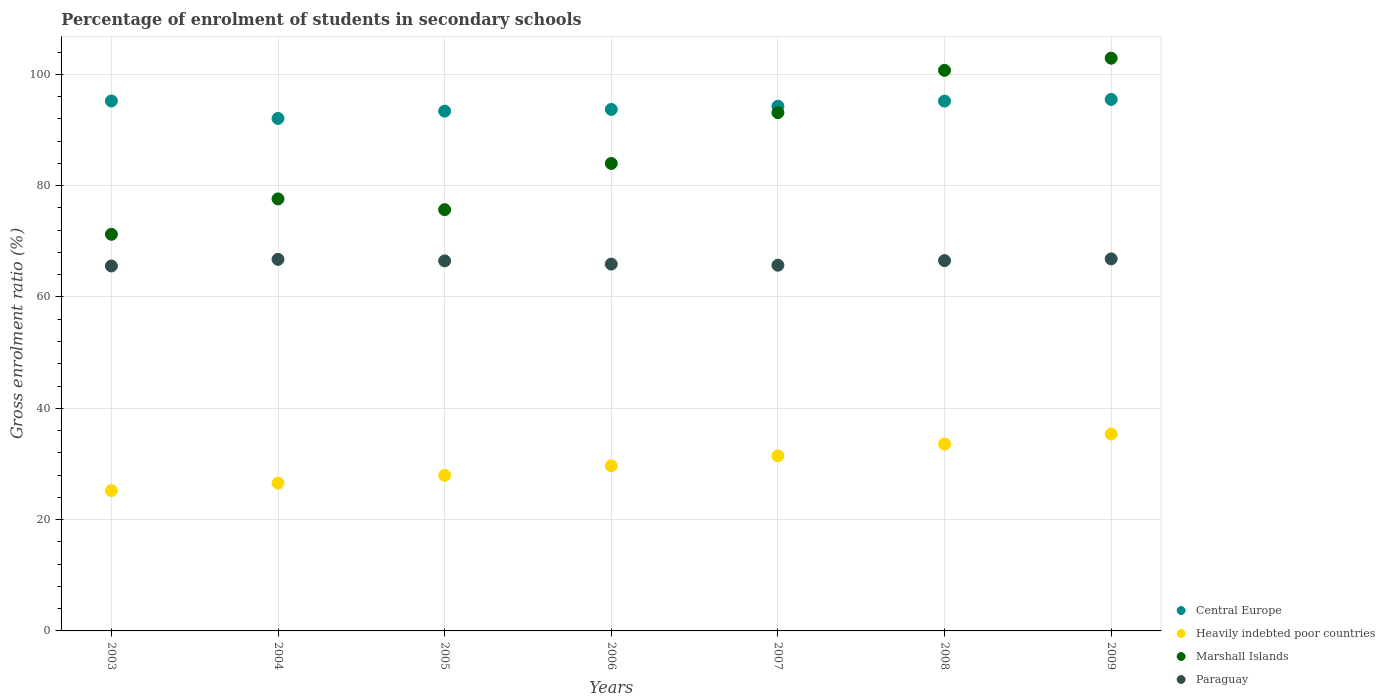What is the percentage of students enrolled in secondary schools in Heavily indebted poor countries in 2006?
Keep it short and to the point. 29.67. Across all years, what is the maximum percentage of students enrolled in secondary schools in Marshall Islands?
Your answer should be very brief. 102.89. Across all years, what is the minimum percentage of students enrolled in secondary schools in Central Europe?
Your answer should be very brief. 92.07. In which year was the percentage of students enrolled in secondary schools in Paraguay maximum?
Offer a terse response. 2009. What is the total percentage of students enrolled in secondary schools in Paraguay in the graph?
Provide a succinct answer. 463.77. What is the difference between the percentage of students enrolled in secondary schools in Paraguay in 2008 and that in 2009?
Provide a succinct answer. -0.3. What is the difference between the percentage of students enrolled in secondary schools in Paraguay in 2005 and the percentage of students enrolled in secondary schools in Central Europe in 2008?
Give a very brief answer. -28.71. What is the average percentage of students enrolled in secondary schools in Marshall Islands per year?
Provide a succinct answer. 86.47. In the year 2003, what is the difference between the percentage of students enrolled in secondary schools in Heavily indebted poor countries and percentage of students enrolled in secondary schools in Marshall Islands?
Provide a short and direct response. -46.05. What is the ratio of the percentage of students enrolled in secondary schools in Marshall Islands in 2006 to that in 2008?
Keep it short and to the point. 0.83. Is the difference between the percentage of students enrolled in secondary schools in Heavily indebted poor countries in 2007 and 2008 greater than the difference between the percentage of students enrolled in secondary schools in Marshall Islands in 2007 and 2008?
Ensure brevity in your answer.  Yes. What is the difference between the highest and the second highest percentage of students enrolled in secondary schools in Marshall Islands?
Your response must be concise. 2.18. What is the difference between the highest and the lowest percentage of students enrolled in secondary schools in Paraguay?
Keep it short and to the point. 1.28. Is it the case that in every year, the sum of the percentage of students enrolled in secondary schools in Central Europe and percentage of students enrolled in secondary schools in Paraguay  is greater than the sum of percentage of students enrolled in secondary schools in Heavily indebted poor countries and percentage of students enrolled in secondary schools in Marshall Islands?
Keep it short and to the point. No. Is it the case that in every year, the sum of the percentage of students enrolled in secondary schools in Heavily indebted poor countries and percentage of students enrolled in secondary schools in Paraguay  is greater than the percentage of students enrolled in secondary schools in Marshall Islands?
Offer a terse response. No. How many dotlines are there?
Provide a short and direct response. 4. How many years are there in the graph?
Provide a succinct answer. 7. What is the difference between two consecutive major ticks on the Y-axis?
Your answer should be very brief. 20. Are the values on the major ticks of Y-axis written in scientific E-notation?
Give a very brief answer. No. Does the graph contain any zero values?
Provide a succinct answer. No. Does the graph contain grids?
Your answer should be very brief. Yes. How many legend labels are there?
Provide a succinct answer. 4. How are the legend labels stacked?
Provide a succinct answer. Vertical. What is the title of the graph?
Your answer should be compact. Percentage of enrolment of students in secondary schools. Does "Brazil" appear as one of the legend labels in the graph?
Ensure brevity in your answer.  No. What is the Gross enrolment ratio (%) of Central Europe in 2003?
Make the answer very short. 95.21. What is the Gross enrolment ratio (%) in Heavily indebted poor countries in 2003?
Keep it short and to the point. 25.2. What is the Gross enrolment ratio (%) of Marshall Islands in 2003?
Keep it short and to the point. 71.26. What is the Gross enrolment ratio (%) in Paraguay in 2003?
Offer a terse response. 65.56. What is the Gross enrolment ratio (%) in Central Europe in 2004?
Ensure brevity in your answer.  92.07. What is the Gross enrolment ratio (%) in Heavily indebted poor countries in 2004?
Your answer should be compact. 26.56. What is the Gross enrolment ratio (%) in Marshall Islands in 2004?
Ensure brevity in your answer.  77.62. What is the Gross enrolment ratio (%) in Paraguay in 2004?
Offer a terse response. 66.76. What is the Gross enrolment ratio (%) in Central Europe in 2005?
Provide a succinct answer. 93.38. What is the Gross enrolment ratio (%) in Heavily indebted poor countries in 2005?
Your answer should be very brief. 27.95. What is the Gross enrolment ratio (%) in Marshall Islands in 2005?
Give a very brief answer. 75.68. What is the Gross enrolment ratio (%) in Paraguay in 2005?
Offer a terse response. 66.48. What is the Gross enrolment ratio (%) of Central Europe in 2006?
Your response must be concise. 93.69. What is the Gross enrolment ratio (%) in Heavily indebted poor countries in 2006?
Ensure brevity in your answer.  29.67. What is the Gross enrolment ratio (%) in Marshall Islands in 2006?
Keep it short and to the point. 83.98. What is the Gross enrolment ratio (%) of Paraguay in 2006?
Make the answer very short. 65.9. What is the Gross enrolment ratio (%) in Central Europe in 2007?
Keep it short and to the point. 94.27. What is the Gross enrolment ratio (%) in Heavily indebted poor countries in 2007?
Your answer should be compact. 31.45. What is the Gross enrolment ratio (%) of Marshall Islands in 2007?
Make the answer very short. 93.11. What is the Gross enrolment ratio (%) in Paraguay in 2007?
Provide a succinct answer. 65.7. What is the Gross enrolment ratio (%) in Central Europe in 2008?
Ensure brevity in your answer.  95.19. What is the Gross enrolment ratio (%) in Heavily indebted poor countries in 2008?
Your answer should be very brief. 33.57. What is the Gross enrolment ratio (%) in Marshall Islands in 2008?
Keep it short and to the point. 100.71. What is the Gross enrolment ratio (%) of Paraguay in 2008?
Keep it short and to the point. 66.53. What is the Gross enrolment ratio (%) of Central Europe in 2009?
Make the answer very short. 95.49. What is the Gross enrolment ratio (%) in Heavily indebted poor countries in 2009?
Make the answer very short. 35.37. What is the Gross enrolment ratio (%) in Marshall Islands in 2009?
Provide a short and direct response. 102.89. What is the Gross enrolment ratio (%) in Paraguay in 2009?
Make the answer very short. 66.84. Across all years, what is the maximum Gross enrolment ratio (%) of Central Europe?
Your answer should be very brief. 95.49. Across all years, what is the maximum Gross enrolment ratio (%) in Heavily indebted poor countries?
Your response must be concise. 35.37. Across all years, what is the maximum Gross enrolment ratio (%) in Marshall Islands?
Provide a short and direct response. 102.89. Across all years, what is the maximum Gross enrolment ratio (%) of Paraguay?
Keep it short and to the point. 66.84. Across all years, what is the minimum Gross enrolment ratio (%) of Central Europe?
Give a very brief answer. 92.07. Across all years, what is the minimum Gross enrolment ratio (%) of Heavily indebted poor countries?
Your answer should be very brief. 25.2. Across all years, what is the minimum Gross enrolment ratio (%) in Marshall Islands?
Give a very brief answer. 71.26. Across all years, what is the minimum Gross enrolment ratio (%) of Paraguay?
Offer a very short reply. 65.56. What is the total Gross enrolment ratio (%) of Central Europe in the graph?
Provide a short and direct response. 659.29. What is the total Gross enrolment ratio (%) in Heavily indebted poor countries in the graph?
Offer a terse response. 209.78. What is the total Gross enrolment ratio (%) of Marshall Islands in the graph?
Offer a very short reply. 605.26. What is the total Gross enrolment ratio (%) of Paraguay in the graph?
Your answer should be very brief. 463.77. What is the difference between the Gross enrolment ratio (%) of Central Europe in 2003 and that in 2004?
Keep it short and to the point. 3.14. What is the difference between the Gross enrolment ratio (%) of Heavily indebted poor countries in 2003 and that in 2004?
Give a very brief answer. -1.36. What is the difference between the Gross enrolment ratio (%) in Marshall Islands in 2003 and that in 2004?
Offer a terse response. -6.36. What is the difference between the Gross enrolment ratio (%) of Paraguay in 2003 and that in 2004?
Ensure brevity in your answer.  -1.19. What is the difference between the Gross enrolment ratio (%) in Central Europe in 2003 and that in 2005?
Give a very brief answer. 1.82. What is the difference between the Gross enrolment ratio (%) in Heavily indebted poor countries in 2003 and that in 2005?
Offer a very short reply. -2.75. What is the difference between the Gross enrolment ratio (%) of Marshall Islands in 2003 and that in 2005?
Give a very brief answer. -4.43. What is the difference between the Gross enrolment ratio (%) of Paraguay in 2003 and that in 2005?
Ensure brevity in your answer.  -0.92. What is the difference between the Gross enrolment ratio (%) in Central Europe in 2003 and that in 2006?
Your response must be concise. 1.52. What is the difference between the Gross enrolment ratio (%) in Heavily indebted poor countries in 2003 and that in 2006?
Your answer should be very brief. -4.47. What is the difference between the Gross enrolment ratio (%) in Marshall Islands in 2003 and that in 2006?
Your response must be concise. -12.73. What is the difference between the Gross enrolment ratio (%) in Paraguay in 2003 and that in 2006?
Provide a short and direct response. -0.34. What is the difference between the Gross enrolment ratio (%) of Central Europe in 2003 and that in 2007?
Offer a very short reply. 0.94. What is the difference between the Gross enrolment ratio (%) of Heavily indebted poor countries in 2003 and that in 2007?
Offer a very short reply. -6.25. What is the difference between the Gross enrolment ratio (%) of Marshall Islands in 2003 and that in 2007?
Ensure brevity in your answer.  -21.86. What is the difference between the Gross enrolment ratio (%) of Paraguay in 2003 and that in 2007?
Provide a short and direct response. -0.14. What is the difference between the Gross enrolment ratio (%) of Central Europe in 2003 and that in 2008?
Offer a very short reply. 0.02. What is the difference between the Gross enrolment ratio (%) in Heavily indebted poor countries in 2003 and that in 2008?
Offer a terse response. -8.36. What is the difference between the Gross enrolment ratio (%) of Marshall Islands in 2003 and that in 2008?
Offer a terse response. -29.46. What is the difference between the Gross enrolment ratio (%) of Paraguay in 2003 and that in 2008?
Give a very brief answer. -0.97. What is the difference between the Gross enrolment ratio (%) in Central Europe in 2003 and that in 2009?
Make the answer very short. -0.28. What is the difference between the Gross enrolment ratio (%) in Heavily indebted poor countries in 2003 and that in 2009?
Provide a short and direct response. -10.16. What is the difference between the Gross enrolment ratio (%) of Marshall Islands in 2003 and that in 2009?
Your answer should be very brief. -31.64. What is the difference between the Gross enrolment ratio (%) in Paraguay in 2003 and that in 2009?
Ensure brevity in your answer.  -1.28. What is the difference between the Gross enrolment ratio (%) of Central Europe in 2004 and that in 2005?
Your answer should be compact. -1.31. What is the difference between the Gross enrolment ratio (%) in Heavily indebted poor countries in 2004 and that in 2005?
Your answer should be very brief. -1.39. What is the difference between the Gross enrolment ratio (%) of Marshall Islands in 2004 and that in 2005?
Make the answer very short. 1.93. What is the difference between the Gross enrolment ratio (%) of Paraguay in 2004 and that in 2005?
Ensure brevity in your answer.  0.27. What is the difference between the Gross enrolment ratio (%) in Central Europe in 2004 and that in 2006?
Your answer should be compact. -1.62. What is the difference between the Gross enrolment ratio (%) of Heavily indebted poor countries in 2004 and that in 2006?
Your answer should be compact. -3.11. What is the difference between the Gross enrolment ratio (%) in Marshall Islands in 2004 and that in 2006?
Your response must be concise. -6.37. What is the difference between the Gross enrolment ratio (%) of Paraguay in 2004 and that in 2006?
Provide a short and direct response. 0.85. What is the difference between the Gross enrolment ratio (%) in Central Europe in 2004 and that in 2007?
Your response must be concise. -2.2. What is the difference between the Gross enrolment ratio (%) in Heavily indebted poor countries in 2004 and that in 2007?
Provide a succinct answer. -4.89. What is the difference between the Gross enrolment ratio (%) in Marshall Islands in 2004 and that in 2007?
Your response must be concise. -15.5. What is the difference between the Gross enrolment ratio (%) in Paraguay in 2004 and that in 2007?
Ensure brevity in your answer.  1.05. What is the difference between the Gross enrolment ratio (%) of Central Europe in 2004 and that in 2008?
Ensure brevity in your answer.  -3.12. What is the difference between the Gross enrolment ratio (%) in Heavily indebted poor countries in 2004 and that in 2008?
Provide a short and direct response. -7. What is the difference between the Gross enrolment ratio (%) of Marshall Islands in 2004 and that in 2008?
Give a very brief answer. -23.1. What is the difference between the Gross enrolment ratio (%) of Paraguay in 2004 and that in 2008?
Offer a terse response. 0.22. What is the difference between the Gross enrolment ratio (%) in Central Europe in 2004 and that in 2009?
Your response must be concise. -3.42. What is the difference between the Gross enrolment ratio (%) of Heavily indebted poor countries in 2004 and that in 2009?
Offer a terse response. -8.8. What is the difference between the Gross enrolment ratio (%) in Marshall Islands in 2004 and that in 2009?
Ensure brevity in your answer.  -25.28. What is the difference between the Gross enrolment ratio (%) in Paraguay in 2004 and that in 2009?
Make the answer very short. -0.08. What is the difference between the Gross enrolment ratio (%) of Central Europe in 2005 and that in 2006?
Keep it short and to the point. -0.31. What is the difference between the Gross enrolment ratio (%) of Heavily indebted poor countries in 2005 and that in 2006?
Provide a short and direct response. -1.72. What is the difference between the Gross enrolment ratio (%) of Marshall Islands in 2005 and that in 2006?
Offer a very short reply. -8.3. What is the difference between the Gross enrolment ratio (%) of Paraguay in 2005 and that in 2006?
Give a very brief answer. 0.58. What is the difference between the Gross enrolment ratio (%) of Central Europe in 2005 and that in 2007?
Provide a short and direct response. -0.88. What is the difference between the Gross enrolment ratio (%) in Heavily indebted poor countries in 2005 and that in 2007?
Offer a very short reply. -3.5. What is the difference between the Gross enrolment ratio (%) in Marshall Islands in 2005 and that in 2007?
Provide a succinct answer. -17.43. What is the difference between the Gross enrolment ratio (%) in Paraguay in 2005 and that in 2007?
Offer a very short reply. 0.78. What is the difference between the Gross enrolment ratio (%) of Central Europe in 2005 and that in 2008?
Provide a short and direct response. -1.8. What is the difference between the Gross enrolment ratio (%) of Heavily indebted poor countries in 2005 and that in 2008?
Make the answer very short. -5.62. What is the difference between the Gross enrolment ratio (%) in Marshall Islands in 2005 and that in 2008?
Your answer should be very brief. -25.03. What is the difference between the Gross enrolment ratio (%) in Paraguay in 2005 and that in 2008?
Give a very brief answer. -0.05. What is the difference between the Gross enrolment ratio (%) of Central Europe in 2005 and that in 2009?
Offer a terse response. -2.1. What is the difference between the Gross enrolment ratio (%) of Heavily indebted poor countries in 2005 and that in 2009?
Give a very brief answer. -7.42. What is the difference between the Gross enrolment ratio (%) in Marshall Islands in 2005 and that in 2009?
Ensure brevity in your answer.  -27.21. What is the difference between the Gross enrolment ratio (%) of Paraguay in 2005 and that in 2009?
Your response must be concise. -0.36. What is the difference between the Gross enrolment ratio (%) of Central Europe in 2006 and that in 2007?
Make the answer very short. -0.57. What is the difference between the Gross enrolment ratio (%) of Heavily indebted poor countries in 2006 and that in 2007?
Give a very brief answer. -1.78. What is the difference between the Gross enrolment ratio (%) of Marshall Islands in 2006 and that in 2007?
Provide a short and direct response. -9.13. What is the difference between the Gross enrolment ratio (%) in Paraguay in 2006 and that in 2007?
Provide a short and direct response. 0.2. What is the difference between the Gross enrolment ratio (%) in Central Europe in 2006 and that in 2008?
Your answer should be very brief. -1.49. What is the difference between the Gross enrolment ratio (%) in Heavily indebted poor countries in 2006 and that in 2008?
Your answer should be compact. -3.89. What is the difference between the Gross enrolment ratio (%) in Marshall Islands in 2006 and that in 2008?
Offer a terse response. -16.73. What is the difference between the Gross enrolment ratio (%) of Paraguay in 2006 and that in 2008?
Offer a terse response. -0.63. What is the difference between the Gross enrolment ratio (%) of Central Europe in 2006 and that in 2009?
Provide a succinct answer. -1.79. What is the difference between the Gross enrolment ratio (%) of Heavily indebted poor countries in 2006 and that in 2009?
Offer a terse response. -5.69. What is the difference between the Gross enrolment ratio (%) of Marshall Islands in 2006 and that in 2009?
Your answer should be compact. -18.91. What is the difference between the Gross enrolment ratio (%) in Paraguay in 2006 and that in 2009?
Keep it short and to the point. -0.93. What is the difference between the Gross enrolment ratio (%) in Central Europe in 2007 and that in 2008?
Make the answer very short. -0.92. What is the difference between the Gross enrolment ratio (%) in Heavily indebted poor countries in 2007 and that in 2008?
Make the answer very short. -2.11. What is the difference between the Gross enrolment ratio (%) in Marshall Islands in 2007 and that in 2008?
Make the answer very short. -7.6. What is the difference between the Gross enrolment ratio (%) in Paraguay in 2007 and that in 2008?
Provide a succinct answer. -0.83. What is the difference between the Gross enrolment ratio (%) of Central Europe in 2007 and that in 2009?
Offer a terse response. -1.22. What is the difference between the Gross enrolment ratio (%) in Heavily indebted poor countries in 2007 and that in 2009?
Your answer should be compact. -3.91. What is the difference between the Gross enrolment ratio (%) in Marshall Islands in 2007 and that in 2009?
Ensure brevity in your answer.  -9.78. What is the difference between the Gross enrolment ratio (%) of Paraguay in 2007 and that in 2009?
Give a very brief answer. -1.14. What is the difference between the Gross enrolment ratio (%) of Central Europe in 2008 and that in 2009?
Your answer should be very brief. -0.3. What is the difference between the Gross enrolment ratio (%) in Heavily indebted poor countries in 2008 and that in 2009?
Ensure brevity in your answer.  -1.8. What is the difference between the Gross enrolment ratio (%) of Marshall Islands in 2008 and that in 2009?
Provide a short and direct response. -2.18. What is the difference between the Gross enrolment ratio (%) of Paraguay in 2008 and that in 2009?
Your answer should be very brief. -0.3. What is the difference between the Gross enrolment ratio (%) in Central Europe in 2003 and the Gross enrolment ratio (%) in Heavily indebted poor countries in 2004?
Your answer should be compact. 68.64. What is the difference between the Gross enrolment ratio (%) of Central Europe in 2003 and the Gross enrolment ratio (%) of Marshall Islands in 2004?
Your response must be concise. 17.59. What is the difference between the Gross enrolment ratio (%) in Central Europe in 2003 and the Gross enrolment ratio (%) in Paraguay in 2004?
Offer a terse response. 28.45. What is the difference between the Gross enrolment ratio (%) of Heavily indebted poor countries in 2003 and the Gross enrolment ratio (%) of Marshall Islands in 2004?
Provide a succinct answer. -52.41. What is the difference between the Gross enrolment ratio (%) of Heavily indebted poor countries in 2003 and the Gross enrolment ratio (%) of Paraguay in 2004?
Make the answer very short. -41.55. What is the difference between the Gross enrolment ratio (%) of Marshall Islands in 2003 and the Gross enrolment ratio (%) of Paraguay in 2004?
Ensure brevity in your answer.  4.5. What is the difference between the Gross enrolment ratio (%) in Central Europe in 2003 and the Gross enrolment ratio (%) in Heavily indebted poor countries in 2005?
Provide a succinct answer. 67.26. What is the difference between the Gross enrolment ratio (%) in Central Europe in 2003 and the Gross enrolment ratio (%) in Marshall Islands in 2005?
Offer a terse response. 19.52. What is the difference between the Gross enrolment ratio (%) of Central Europe in 2003 and the Gross enrolment ratio (%) of Paraguay in 2005?
Offer a very short reply. 28.73. What is the difference between the Gross enrolment ratio (%) of Heavily indebted poor countries in 2003 and the Gross enrolment ratio (%) of Marshall Islands in 2005?
Make the answer very short. -50.48. What is the difference between the Gross enrolment ratio (%) of Heavily indebted poor countries in 2003 and the Gross enrolment ratio (%) of Paraguay in 2005?
Provide a succinct answer. -41.28. What is the difference between the Gross enrolment ratio (%) of Marshall Islands in 2003 and the Gross enrolment ratio (%) of Paraguay in 2005?
Keep it short and to the point. 4.78. What is the difference between the Gross enrolment ratio (%) of Central Europe in 2003 and the Gross enrolment ratio (%) of Heavily indebted poor countries in 2006?
Your response must be concise. 65.54. What is the difference between the Gross enrolment ratio (%) of Central Europe in 2003 and the Gross enrolment ratio (%) of Marshall Islands in 2006?
Your response must be concise. 11.23. What is the difference between the Gross enrolment ratio (%) of Central Europe in 2003 and the Gross enrolment ratio (%) of Paraguay in 2006?
Provide a succinct answer. 29.3. What is the difference between the Gross enrolment ratio (%) of Heavily indebted poor countries in 2003 and the Gross enrolment ratio (%) of Marshall Islands in 2006?
Your response must be concise. -58.78. What is the difference between the Gross enrolment ratio (%) of Heavily indebted poor countries in 2003 and the Gross enrolment ratio (%) of Paraguay in 2006?
Provide a succinct answer. -40.7. What is the difference between the Gross enrolment ratio (%) in Marshall Islands in 2003 and the Gross enrolment ratio (%) in Paraguay in 2006?
Your response must be concise. 5.35. What is the difference between the Gross enrolment ratio (%) in Central Europe in 2003 and the Gross enrolment ratio (%) in Heavily indebted poor countries in 2007?
Your answer should be very brief. 63.75. What is the difference between the Gross enrolment ratio (%) of Central Europe in 2003 and the Gross enrolment ratio (%) of Marshall Islands in 2007?
Give a very brief answer. 2.09. What is the difference between the Gross enrolment ratio (%) in Central Europe in 2003 and the Gross enrolment ratio (%) in Paraguay in 2007?
Your response must be concise. 29.51. What is the difference between the Gross enrolment ratio (%) of Heavily indebted poor countries in 2003 and the Gross enrolment ratio (%) of Marshall Islands in 2007?
Provide a succinct answer. -67.91. What is the difference between the Gross enrolment ratio (%) of Heavily indebted poor countries in 2003 and the Gross enrolment ratio (%) of Paraguay in 2007?
Ensure brevity in your answer.  -40.5. What is the difference between the Gross enrolment ratio (%) of Marshall Islands in 2003 and the Gross enrolment ratio (%) of Paraguay in 2007?
Give a very brief answer. 5.56. What is the difference between the Gross enrolment ratio (%) in Central Europe in 2003 and the Gross enrolment ratio (%) in Heavily indebted poor countries in 2008?
Ensure brevity in your answer.  61.64. What is the difference between the Gross enrolment ratio (%) of Central Europe in 2003 and the Gross enrolment ratio (%) of Marshall Islands in 2008?
Your answer should be compact. -5.51. What is the difference between the Gross enrolment ratio (%) of Central Europe in 2003 and the Gross enrolment ratio (%) of Paraguay in 2008?
Your response must be concise. 28.67. What is the difference between the Gross enrolment ratio (%) in Heavily indebted poor countries in 2003 and the Gross enrolment ratio (%) in Marshall Islands in 2008?
Keep it short and to the point. -75.51. What is the difference between the Gross enrolment ratio (%) in Heavily indebted poor countries in 2003 and the Gross enrolment ratio (%) in Paraguay in 2008?
Make the answer very short. -41.33. What is the difference between the Gross enrolment ratio (%) of Marshall Islands in 2003 and the Gross enrolment ratio (%) of Paraguay in 2008?
Provide a succinct answer. 4.72. What is the difference between the Gross enrolment ratio (%) in Central Europe in 2003 and the Gross enrolment ratio (%) in Heavily indebted poor countries in 2009?
Ensure brevity in your answer.  59.84. What is the difference between the Gross enrolment ratio (%) of Central Europe in 2003 and the Gross enrolment ratio (%) of Marshall Islands in 2009?
Offer a terse response. -7.68. What is the difference between the Gross enrolment ratio (%) in Central Europe in 2003 and the Gross enrolment ratio (%) in Paraguay in 2009?
Provide a short and direct response. 28.37. What is the difference between the Gross enrolment ratio (%) in Heavily indebted poor countries in 2003 and the Gross enrolment ratio (%) in Marshall Islands in 2009?
Make the answer very short. -77.69. What is the difference between the Gross enrolment ratio (%) of Heavily indebted poor countries in 2003 and the Gross enrolment ratio (%) of Paraguay in 2009?
Make the answer very short. -41.63. What is the difference between the Gross enrolment ratio (%) of Marshall Islands in 2003 and the Gross enrolment ratio (%) of Paraguay in 2009?
Your response must be concise. 4.42. What is the difference between the Gross enrolment ratio (%) of Central Europe in 2004 and the Gross enrolment ratio (%) of Heavily indebted poor countries in 2005?
Your answer should be compact. 64.12. What is the difference between the Gross enrolment ratio (%) of Central Europe in 2004 and the Gross enrolment ratio (%) of Marshall Islands in 2005?
Your answer should be compact. 16.39. What is the difference between the Gross enrolment ratio (%) of Central Europe in 2004 and the Gross enrolment ratio (%) of Paraguay in 2005?
Your answer should be compact. 25.59. What is the difference between the Gross enrolment ratio (%) of Heavily indebted poor countries in 2004 and the Gross enrolment ratio (%) of Marshall Islands in 2005?
Give a very brief answer. -49.12. What is the difference between the Gross enrolment ratio (%) in Heavily indebted poor countries in 2004 and the Gross enrolment ratio (%) in Paraguay in 2005?
Your response must be concise. -39.92. What is the difference between the Gross enrolment ratio (%) in Marshall Islands in 2004 and the Gross enrolment ratio (%) in Paraguay in 2005?
Your answer should be compact. 11.13. What is the difference between the Gross enrolment ratio (%) of Central Europe in 2004 and the Gross enrolment ratio (%) of Heavily indebted poor countries in 2006?
Give a very brief answer. 62.4. What is the difference between the Gross enrolment ratio (%) in Central Europe in 2004 and the Gross enrolment ratio (%) in Marshall Islands in 2006?
Make the answer very short. 8.09. What is the difference between the Gross enrolment ratio (%) in Central Europe in 2004 and the Gross enrolment ratio (%) in Paraguay in 2006?
Offer a very short reply. 26.17. What is the difference between the Gross enrolment ratio (%) of Heavily indebted poor countries in 2004 and the Gross enrolment ratio (%) of Marshall Islands in 2006?
Provide a short and direct response. -57.42. What is the difference between the Gross enrolment ratio (%) of Heavily indebted poor countries in 2004 and the Gross enrolment ratio (%) of Paraguay in 2006?
Your answer should be compact. -39.34. What is the difference between the Gross enrolment ratio (%) in Marshall Islands in 2004 and the Gross enrolment ratio (%) in Paraguay in 2006?
Keep it short and to the point. 11.71. What is the difference between the Gross enrolment ratio (%) in Central Europe in 2004 and the Gross enrolment ratio (%) in Heavily indebted poor countries in 2007?
Give a very brief answer. 60.62. What is the difference between the Gross enrolment ratio (%) of Central Europe in 2004 and the Gross enrolment ratio (%) of Marshall Islands in 2007?
Ensure brevity in your answer.  -1.04. What is the difference between the Gross enrolment ratio (%) in Central Europe in 2004 and the Gross enrolment ratio (%) in Paraguay in 2007?
Offer a very short reply. 26.37. What is the difference between the Gross enrolment ratio (%) in Heavily indebted poor countries in 2004 and the Gross enrolment ratio (%) in Marshall Islands in 2007?
Keep it short and to the point. -66.55. What is the difference between the Gross enrolment ratio (%) of Heavily indebted poor countries in 2004 and the Gross enrolment ratio (%) of Paraguay in 2007?
Make the answer very short. -39.14. What is the difference between the Gross enrolment ratio (%) of Marshall Islands in 2004 and the Gross enrolment ratio (%) of Paraguay in 2007?
Make the answer very short. 11.91. What is the difference between the Gross enrolment ratio (%) of Central Europe in 2004 and the Gross enrolment ratio (%) of Heavily indebted poor countries in 2008?
Your answer should be very brief. 58.5. What is the difference between the Gross enrolment ratio (%) in Central Europe in 2004 and the Gross enrolment ratio (%) in Marshall Islands in 2008?
Offer a terse response. -8.64. What is the difference between the Gross enrolment ratio (%) of Central Europe in 2004 and the Gross enrolment ratio (%) of Paraguay in 2008?
Provide a short and direct response. 25.54. What is the difference between the Gross enrolment ratio (%) of Heavily indebted poor countries in 2004 and the Gross enrolment ratio (%) of Marshall Islands in 2008?
Keep it short and to the point. -74.15. What is the difference between the Gross enrolment ratio (%) of Heavily indebted poor countries in 2004 and the Gross enrolment ratio (%) of Paraguay in 2008?
Offer a terse response. -39.97. What is the difference between the Gross enrolment ratio (%) in Marshall Islands in 2004 and the Gross enrolment ratio (%) in Paraguay in 2008?
Offer a terse response. 11.08. What is the difference between the Gross enrolment ratio (%) in Central Europe in 2004 and the Gross enrolment ratio (%) in Heavily indebted poor countries in 2009?
Ensure brevity in your answer.  56.7. What is the difference between the Gross enrolment ratio (%) in Central Europe in 2004 and the Gross enrolment ratio (%) in Marshall Islands in 2009?
Keep it short and to the point. -10.82. What is the difference between the Gross enrolment ratio (%) in Central Europe in 2004 and the Gross enrolment ratio (%) in Paraguay in 2009?
Keep it short and to the point. 25.23. What is the difference between the Gross enrolment ratio (%) of Heavily indebted poor countries in 2004 and the Gross enrolment ratio (%) of Marshall Islands in 2009?
Keep it short and to the point. -76.33. What is the difference between the Gross enrolment ratio (%) of Heavily indebted poor countries in 2004 and the Gross enrolment ratio (%) of Paraguay in 2009?
Keep it short and to the point. -40.27. What is the difference between the Gross enrolment ratio (%) of Marshall Islands in 2004 and the Gross enrolment ratio (%) of Paraguay in 2009?
Make the answer very short. 10.78. What is the difference between the Gross enrolment ratio (%) of Central Europe in 2005 and the Gross enrolment ratio (%) of Heavily indebted poor countries in 2006?
Give a very brief answer. 63.71. What is the difference between the Gross enrolment ratio (%) in Central Europe in 2005 and the Gross enrolment ratio (%) in Marshall Islands in 2006?
Keep it short and to the point. 9.4. What is the difference between the Gross enrolment ratio (%) in Central Europe in 2005 and the Gross enrolment ratio (%) in Paraguay in 2006?
Give a very brief answer. 27.48. What is the difference between the Gross enrolment ratio (%) in Heavily indebted poor countries in 2005 and the Gross enrolment ratio (%) in Marshall Islands in 2006?
Ensure brevity in your answer.  -56.03. What is the difference between the Gross enrolment ratio (%) in Heavily indebted poor countries in 2005 and the Gross enrolment ratio (%) in Paraguay in 2006?
Keep it short and to the point. -37.95. What is the difference between the Gross enrolment ratio (%) of Marshall Islands in 2005 and the Gross enrolment ratio (%) of Paraguay in 2006?
Ensure brevity in your answer.  9.78. What is the difference between the Gross enrolment ratio (%) of Central Europe in 2005 and the Gross enrolment ratio (%) of Heavily indebted poor countries in 2007?
Give a very brief answer. 61.93. What is the difference between the Gross enrolment ratio (%) of Central Europe in 2005 and the Gross enrolment ratio (%) of Marshall Islands in 2007?
Make the answer very short. 0.27. What is the difference between the Gross enrolment ratio (%) in Central Europe in 2005 and the Gross enrolment ratio (%) in Paraguay in 2007?
Your answer should be compact. 27.68. What is the difference between the Gross enrolment ratio (%) of Heavily indebted poor countries in 2005 and the Gross enrolment ratio (%) of Marshall Islands in 2007?
Offer a terse response. -65.17. What is the difference between the Gross enrolment ratio (%) of Heavily indebted poor countries in 2005 and the Gross enrolment ratio (%) of Paraguay in 2007?
Keep it short and to the point. -37.75. What is the difference between the Gross enrolment ratio (%) in Marshall Islands in 2005 and the Gross enrolment ratio (%) in Paraguay in 2007?
Your answer should be compact. 9.98. What is the difference between the Gross enrolment ratio (%) in Central Europe in 2005 and the Gross enrolment ratio (%) in Heavily indebted poor countries in 2008?
Give a very brief answer. 59.82. What is the difference between the Gross enrolment ratio (%) in Central Europe in 2005 and the Gross enrolment ratio (%) in Marshall Islands in 2008?
Provide a succinct answer. -7.33. What is the difference between the Gross enrolment ratio (%) of Central Europe in 2005 and the Gross enrolment ratio (%) of Paraguay in 2008?
Offer a very short reply. 26.85. What is the difference between the Gross enrolment ratio (%) of Heavily indebted poor countries in 2005 and the Gross enrolment ratio (%) of Marshall Islands in 2008?
Provide a succinct answer. -72.76. What is the difference between the Gross enrolment ratio (%) in Heavily indebted poor countries in 2005 and the Gross enrolment ratio (%) in Paraguay in 2008?
Give a very brief answer. -38.58. What is the difference between the Gross enrolment ratio (%) in Marshall Islands in 2005 and the Gross enrolment ratio (%) in Paraguay in 2008?
Make the answer very short. 9.15. What is the difference between the Gross enrolment ratio (%) in Central Europe in 2005 and the Gross enrolment ratio (%) in Heavily indebted poor countries in 2009?
Provide a succinct answer. 58.02. What is the difference between the Gross enrolment ratio (%) in Central Europe in 2005 and the Gross enrolment ratio (%) in Marshall Islands in 2009?
Keep it short and to the point. -9.51. What is the difference between the Gross enrolment ratio (%) in Central Europe in 2005 and the Gross enrolment ratio (%) in Paraguay in 2009?
Your response must be concise. 26.55. What is the difference between the Gross enrolment ratio (%) of Heavily indebted poor countries in 2005 and the Gross enrolment ratio (%) of Marshall Islands in 2009?
Ensure brevity in your answer.  -74.94. What is the difference between the Gross enrolment ratio (%) in Heavily indebted poor countries in 2005 and the Gross enrolment ratio (%) in Paraguay in 2009?
Offer a very short reply. -38.89. What is the difference between the Gross enrolment ratio (%) in Marshall Islands in 2005 and the Gross enrolment ratio (%) in Paraguay in 2009?
Your answer should be compact. 8.85. What is the difference between the Gross enrolment ratio (%) of Central Europe in 2006 and the Gross enrolment ratio (%) of Heavily indebted poor countries in 2007?
Offer a terse response. 62.24. What is the difference between the Gross enrolment ratio (%) of Central Europe in 2006 and the Gross enrolment ratio (%) of Marshall Islands in 2007?
Provide a short and direct response. 0.58. What is the difference between the Gross enrolment ratio (%) of Central Europe in 2006 and the Gross enrolment ratio (%) of Paraguay in 2007?
Your response must be concise. 27.99. What is the difference between the Gross enrolment ratio (%) in Heavily indebted poor countries in 2006 and the Gross enrolment ratio (%) in Marshall Islands in 2007?
Provide a succinct answer. -63.44. What is the difference between the Gross enrolment ratio (%) in Heavily indebted poor countries in 2006 and the Gross enrolment ratio (%) in Paraguay in 2007?
Offer a terse response. -36.03. What is the difference between the Gross enrolment ratio (%) in Marshall Islands in 2006 and the Gross enrolment ratio (%) in Paraguay in 2007?
Provide a succinct answer. 18.28. What is the difference between the Gross enrolment ratio (%) in Central Europe in 2006 and the Gross enrolment ratio (%) in Heavily indebted poor countries in 2008?
Your response must be concise. 60.12. What is the difference between the Gross enrolment ratio (%) in Central Europe in 2006 and the Gross enrolment ratio (%) in Marshall Islands in 2008?
Provide a short and direct response. -7.02. What is the difference between the Gross enrolment ratio (%) of Central Europe in 2006 and the Gross enrolment ratio (%) of Paraguay in 2008?
Your answer should be compact. 27.16. What is the difference between the Gross enrolment ratio (%) in Heavily indebted poor countries in 2006 and the Gross enrolment ratio (%) in Marshall Islands in 2008?
Your answer should be very brief. -71.04. What is the difference between the Gross enrolment ratio (%) in Heavily indebted poor countries in 2006 and the Gross enrolment ratio (%) in Paraguay in 2008?
Keep it short and to the point. -36.86. What is the difference between the Gross enrolment ratio (%) of Marshall Islands in 2006 and the Gross enrolment ratio (%) of Paraguay in 2008?
Provide a short and direct response. 17.45. What is the difference between the Gross enrolment ratio (%) of Central Europe in 2006 and the Gross enrolment ratio (%) of Heavily indebted poor countries in 2009?
Keep it short and to the point. 58.33. What is the difference between the Gross enrolment ratio (%) of Central Europe in 2006 and the Gross enrolment ratio (%) of Marshall Islands in 2009?
Provide a short and direct response. -9.2. What is the difference between the Gross enrolment ratio (%) in Central Europe in 2006 and the Gross enrolment ratio (%) in Paraguay in 2009?
Keep it short and to the point. 26.86. What is the difference between the Gross enrolment ratio (%) in Heavily indebted poor countries in 2006 and the Gross enrolment ratio (%) in Marshall Islands in 2009?
Offer a very short reply. -73.22. What is the difference between the Gross enrolment ratio (%) of Heavily indebted poor countries in 2006 and the Gross enrolment ratio (%) of Paraguay in 2009?
Keep it short and to the point. -37.16. What is the difference between the Gross enrolment ratio (%) in Marshall Islands in 2006 and the Gross enrolment ratio (%) in Paraguay in 2009?
Make the answer very short. 17.15. What is the difference between the Gross enrolment ratio (%) in Central Europe in 2007 and the Gross enrolment ratio (%) in Heavily indebted poor countries in 2008?
Provide a short and direct response. 60.7. What is the difference between the Gross enrolment ratio (%) of Central Europe in 2007 and the Gross enrolment ratio (%) of Marshall Islands in 2008?
Keep it short and to the point. -6.45. What is the difference between the Gross enrolment ratio (%) of Central Europe in 2007 and the Gross enrolment ratio (%) of Paraguay in 2008?
Give a very brief answer. 27.73. What is the difference between the Gross enrolment ratio (%) in Heavily indebted poor countries in 2007 and the Gross enrolment ratio (%) in Marshall Islands in 2008?
Provide a succinct answer. -69.26. What is the difference between the Gross enrolment ratio (%) in Heavily indebted poor countries in 2007 and the Gross enrolment ratio (%) in Paraguay in 2008?
Provide a succinct answer. -35.08. What is the difference between the Gross enrolment ratio (%) of Marshall Islands in 2007 and the Gross enrolment ratio (%) of Paraguay in 2008?
Give a very brief answer. 26.58. What is the difference between the Gross enrolment ratio (%) of Central Europe in 2007 and the Gross enrolment ratio (%) of Heavily indebted poor countries in 2009?
Ensure brevity in your answer.  58.9. What is the difference between the Gross enrolment ratio (%) of Central Europe in 2007 and the Gross enrolment ratio (%) of Marshall Islands in 2009?
Provide a short and direct response. -8.63. What is the difference between the Gross enrolment ratio (%) of Central Europe in 2007 and the Gross enrolment ratio (%) of Paraguay in 2009?
Make the answer very short. 27.43. What is the difference between the Gross enrolment ratio (%) of Heavily indebted poor countries in 2007 and the Gross enrolment ratio (%) of Marshall Islands in 2009?
Make the answer very short. -71.44. What is the difference between the Gross enrolment ratio (%) in Heavily indebted poor countries in 2007 and the Gross enrolment ratio (%) in Paraguay in 2009?
Offer a very short reply. -35.38. What is the difference between the Gross enrolment ratio (%) of Marshall Islands in 2007 and the Gross enrolment ratio (%) of Paraguay in 2009?
Your answer should be very brief. 26.28. What is the difference between the Gross enrolment ratio (%) of Central Europe in 2008 and the Gross enrolment ratio (%) of Heavily indebted poor countries in 2009?
Provide a succinct answer. 59.82. What is the difference between the Gross enrolment ratio (%) in Central Europe in 2008 and the Gross enrolment ratio (%) in Marshall Islands in 2009?
Offer a very short reply. -7.71. What is the difference between the Gross enrolment ratio (%) of Central Europe in 2008 and the Gross enrolment ratio (%) of Paraguay in 2009?
Your answer should be compact. 28.35. What is the difference between the Gross enrolment ratio (%) of Heavily indebted poor countries in 2008 and the Gross enrolment ratio (%) of Marshall Islands in 2009?
Offer a very short reply. -69.33. What is the difference between the Gross enrolment ratio (%) in Heavily indebted poor countries in 2008 and the Gross enrolment ratio (%) in Paraguay in 2009?
Your response must be concise. -33.27. What is the difference between the Gross enrolment ratio (%) of Marshall Islands in 2008 and the Gross enrolment ratio (%) of Paraguay in 2009?
Your answer should be very brief. 33.88. What is the average Gross enrolment ratio (%) in Central Europe per year?
Offer a very short reply. 94.18. What is the average Gross enrolment ratio (%) in Heavily indebted poor countries per year?
Ensure brevity in your answer.  29.97. What is the average Gross enrolment ratio (%) in Marshall Islands per year?
Offer a terse response. 86.47. What is the average Gross enrolment ratio (%) in Paraguay per year?
Provide a succinct answer. 66.25. In the year 2003, what is the difference between the Gross enrolment ratio (%) in Central Europe and Gross enrolment ratio (%) in Heavily indebted poor countries?
Offer a very short reply. 70. In the year 2003, what is the difference between the Gross enrolment ratio (%) of Central Europe and Gross enrolment ratio (%) of Marshall Islands?
Provide a short and direct response. 23.95. In the year 2003, what is the difference between the Gross enrolment ratio (%) of Central Europe and Gross enrolment ratio (%) of Paraguay?
Your answer should be very brief. 29.65. In the year 2003, what is the difference between the Gross enrolment ratio (%) of Heavily indebted poor countries and Gross enrolment ratio (%) of Marshall Islands?
Make the answer very short. -46.05. In the year 2003, what is the difference between the Gross enrolment ratio (%) of Heavily indebted poor countries and Gross enrolment ratio (%) of Paraguay?
Make the answer very short. -40.36. In the year 2003, what is the difference between the Gross enrolment ratio (%) in Marshall Islands and Gross enrolment ratio (%) in Paraguay?
Your response must be concise. 5.7. In the year 2004, what is the difference between the Gross enrolment ratio (%) of Central Europe and Gross enrolment ratio (%) of Heavily indebted poor countries?
Give a very brief answer. 65.51. In the year 2004, what is the difference between the Gross enrolment ratio (%) in Central Europe and Gross enrolment ratio (%) in Marshall Islands?
Your answer should be compact. 14.45. In the year 2004, what is the difference between the Gross enrolment ratio (%) of Central Europe and Gross enrolment ratio (%) of Paraguay?
Your answer should be compact. 25.31. In the year 2004, what is the difference between the Gross enrolment ratio (%) in Heavily indebted poor countries and Gross enrolment ratio (%) in Marshall Islands?
Your answer should be compact. -51.05. In the year 2004, what is the difference between the Gross enrolment ratio (%) of Heavily indebted poor countries and Gross enrolment ratio (%) of Paraguay?
Ensure brevity in your answer.  -40.19. In the year 2004, what is the difference between the Gross enrolment ratio (%) of Marshall Islands and Gross enrolment ratio (%) of Paraguay?
Your answer should be very brief. 10.86. In the year 2005, what is the difference between the Gross enrolment ratio (%) of Central Europe and Gross enrolment ratio (%) of Heavily indebted poor countries?
Your answer should be very brief. 65.43. In the year 2005, what is the difference between the Gross enrolment ratio (%) of Central Europe and Gross enrolment ratio (%) of Marshall Islands?
Your answer should be very brief. 17.7. In the year 2005, what is the difference between the Gross enrolment ratio (%) in Central Europe and Gross enrolment ratio (%) in Paraguay?
Provide a succinct answer. 26.9. In the year 2005, what is the difference between the Gross enrolment ratio (%) in Heavily indebted poor countries and Gross enrolment ratio (%) in Marshall Islands?
Provide a short and direct response. -47.73. In the year 2005, what is the difference between the Gross enrolment ratio (%) of Heavily indebted poor countries and Gross enrolment ratio (%) of Paraguay?
Your answer should be compact. -38.53. In the year 2005, what is the difference between the Gross enrolment ratio (%) of Marshall Islands and Gross enrolment ratio (%) of Paraguay?
Make the answer very short. 9.2. In the year 2006, what is the difference between the Gross enrolment ratio (%) in Central Europe and Gross enrolment ratio (%) in Heavily indebted poor countries?
Offer a terse response. 64.02. In the year 2006, what is the difference between the Gross enrolment ratio (%) in Central Europe and Gross enrolment ratio (%) in Marshall Islands?
Offer a terse response. 9.71. In the year 2006, what is the difference between the Gross enrolment ratio (%) in Central Europe and Gross enrolment ratio (%) in Paraguay?
Your answer should be compact. 27.79. In the year 2006, what is the difference between the Gross enrolment ratio (%) of Heavily indebted poor countries and Gross enrolment ratio (%) of Marshall Islands?
Give a very brief answer. -54.31. In the year 2006, what is the difference between the Gross enrolment ratio (%) of Heavily indebted poor countries and Gross enrolment ratio (%) of Paraguay?
Your response must be concise. -36.23. In the year 2006, what is the difference between the Gross enrolment ratio (%) in Marshall Islands and Gross enrolment ratio (%) in Paraguay?
Your answer should be compact. 18.08. In the year 2007, what is the difference between the Gross enrolment ratio (%) in Central Europe and Gross enrolment ratio (%) in Heavily indebted poor countries?
Your answer should be compact. 62.81. In the year 2007, what is the difference between the Gross enrolment ratio (%) in Central Europe and Gross enrolment ratio (%) in Marshall Islands?
Give a very brief answer. 1.15. In the year 2007, what is the difference between the Gross enrolment ratio (%) of Central Europe and Gross enrolment ratio (%) of Paraguay?
Provide a short and direct response. 28.57. In the year 2007, what is the difference between the Gross enrolment ratio (%) in Heavily indebted poor countries and Gross enrolment ratio (%) in Marshall Islands?
Offer a very short reply. -61.66. In the year 2007, what is the difference between the Gross enrolment ratio (%) of Heavily indebted poor countries and Gross enrolment ratio (%) of Paraguay?
Make the answer very short. -34.25. In the year 2007, what is the difference between the Gross enrolment ratio (%) of Marshall Islands and Gross enrolment ratio (%) of Paraguay?
Give a very brief answer. 27.41. In the year 2008, what is the difference between the Gross enrolment ratio (%) of Central Europe and Gross enrolment ratio (%) of Heavily indebted poor countries?
Ensure brevity in your answer.  61.62. In the year 2008, what is the difference between the Gross enrolment ratio (%) of Central Europe and Gross enrolment ratio (%) of Marshall Islands?
Your answer should be very brief. -5.53. In the year 2008, what is the difference between the Gross enrolment ratio (%) in Central Europe and Gross enrolment ratio (%) in Paraguay?
Your response must be concise. 28.65. In the year 2008, what is the difference between the Gross enrolment ratio (%) of Heavily indebted poor countries and Gross enrolment ratio (%) of Marshall Islands?
Provide a short and direct response. -67.15. In the year 2008, what is the difference between the Gross enrolment ratio (%) of Heavily indebted poor countries and Gross enrolment ratio (%) of Paraguay?
Give a very brief answer. -32.97. In the year 2008, what is the difference between the Gross enrolment ratio (%) of Marshall Islands and Gross enrolment ratio (%) of Paraguay?
Your answer should be compact. 34.18. In the year 2009, what is the difference between the Gross enrolment ratio (%) of Central Europe and Gross enrolment ratio (%) of Heavily indebted poor countries?
Ensure brevity in your answer.  60.12. In the year 2009, what is the difference between the Gross enrolment ratio (%) in Central Europe and Gross enrolment ratio (%) in Marshall Islands?
Provide a short and direct response. -7.41. In the year 2009, what is the difference between the Gross enrolment ratio (%) of Central Europe and Gross enrolment ratio (%) of Paraguay?
Provide a short and direct response. 28.65. In the year 2009, what is the difference between the Gross enrolment ratio (%) in Heavily indebted poor countries and Gross enrolment ratio (%) in Marshall Islands?
Offer a terse response. -67.53. In the year 2009, what is the difference between the Gross enrolment ratio (%) in Heavily indebted poor countries and Gross enrolment ratio (%) in Paraguay?
Offer a very short reply. -31.47. In the year 2009, what is the difference between the Gross enrolment ratio (%) in Marshall Islands and Gross enrolment ratio (%) in Paraguay?
Your answer should be very brief. 36.06. What is the ratio of the Gross enrolment ratio (%) of Central Europe in 2003 to that in 2004?
Give a very brief answer. 1.03. What is the ratio of the Gross enrolment ratio (%) in Heavily indebted poor countries in 2003 to that in 2004?
Ensure brevity in your answer.  0.95. What is the ratio of the Gross enrolment ratio (%) of Marshall Islands in 2003 to that in 2004?
Your answer should be compact. 0.92. What is the ratio of the Gross enrolment ratio (%) of Paraguay in 2003 to that in 2004?
Make the answer very short. 0.98. What is the ratio of the Gross enrolment ratio (%) of Central Europe in 2003 to that in 2005?
Your answer should be very brief. 1.02. What is the ratio of the Gross enrolment ratio (%) of Heavily indebted poor countries in 2003 to that in 2005?
Your response must be concise. 0.9. What is the ratio of the Gross enrolment ratio (%) in Marshall Islands in 2003 to that in 2005?
Offer a very short reply. 0.94. What is the ratio of the Gross enrolment ratio (%) in Paraguay in 2003 to that in 2005?
Provide a succinct answer. 0.99. What is the ratio of the Gross enrolment ratio (%) in Central Europe in 2003 to that in 2006?
Your response must be concise. 1.02. What is the ratio of the Gross enrolment ratio (%) of Heavily indebted poor countries in 2003 to that in 2006?
Offer a very short reply. 0.85. What is the ratio of the Gross enrolment ratio (%) of Marshall Islands in 2003 to that in 2006?
Your response must be concise. 0.85. What is the ratio of the Gross enrolment ratio (%) in Heavily indebted poor countries in 2003 to that in 2007?
Provide a succinct answer. 0.8. What is the ratio of the Gross enrolment ratio (%) of Marshall Islands in 2003 to that in 2007?
Your response must be concise. 0.77. What is the ratio of the Gross enrolment ratio (%) of Paraguay in 2003 to that in 2007?
Keep it short and to the point. 1. What is the ratio of the Gross enrolment ratio (%) of Heavily indebted poor countries in 2003 to that in 2008?
Your answer should be very brief. 0.75. What is the ratio of the Gross enrolment ratio (%) in Marshall Islands in 2003 to that in 2008?
Your response must be concise. 0.71. What is the ratio of the Gross enrolment ratio (%) in Paraguay in 2003 to that in 2008?
Provide a succinct answer. 0.99. What is the ratio of the Gross enrolment ratio (%) in Heavily indebted poor countries in 2003 to that in 2009?
Ensure brevity in your answer.  0.71. What is the ratio of the Gross enrolment ratio (%) of Marshall Islands in 2003 to that in 2009?
Your answer should be compact. 0.69. What is the ratio of the Gross enrolment ratio (%) in Paraguay in 2003 to that in 2009?
Your response must be concise. 0.98. What is the ratio of the Gross enrolment ratio (%) in Central Europe in 2004 to that in 2005?
Your answer should be very brief. 0.99. What is the ratio of the Gross enrolment ratio (%) of Heavily indebted poor countries in 2004 to that in 2005?
Your answer should be compact. 0.95. What is the ratio of the Gross enrolment ratio (%) in Marshall Islands in 2004 to that in 2005?
Offer a very short reply. 1.03. What is the ratio of the Gross enrolment ratio (%) of Central Europe in 2004 to that in 2006?
Ensure brevity in your answer.  0.98. What is the ratio of the Gross enrolment ratio (%) in Heavily indebted poor countries in 2004 to that in 2006?
Your answer should be compact. 0.9. What is the ratio of the Gross enrolment ratio (%) of Marshall Islands in 2004 to that in 2006?
Provide a short and direct response. 0.92. What is the ratio of the Gross enrolment ratio (%) in Paraguay in 2004 to that in 2006?
Offer a terse response. 1.01. What is the ratio of the Gross enrolment ratio (%) of Central Europe in 2004 to that in 2007?
Ensure brevity in your answer.  0.98. What is the ratio of the Gross enrolment ratio (%) in Heavily indebted poor countries in 2004 to that in 2007?
Your answer should be very brief. 0.84. What is the ratio of the Gross enrolment ratio (%) in Marshall Islands in 2004 to that in 2007?
Make the answer very short. 0.83. What is the ratio of the Gross enrolment ratio (%) in Central Europe in 2004 to that in 2008?
Your answer should be very brief. 0.97. What is the ratio of the Gross enrolment ratio (%) of Heavily indebted poor countries in 2004 to that in 2008?
Offer a very short reply. 0.79. What is the ratio of the Gross enrolment ratio (%) in Marshall Islands in 2004 to that in 2008?
Your answer should be very brief. 0.77. What is the ratio of the Gross enrolment ratio (%) in Paraguay in 2004 to that in 2008?
Give a very brief answer. 1. What is the ratio of the Gross enrolment ratio (%) of Central Europe in 2004 to that in 2009?
Make the answer very short. 0.96. What is the ratio of the Gross enrolment ratio (%) in Heavily indebted poor countries in 2004 to that in 2009?
Provide a short and direct response. 0.75. What is the ratio of the Gross enrolment ratio (%) of Marshall Islands in 2004 to that in 2009?
Offer a very short reply. 0.75. What is the ratio of the Gross enrolment ratio (%) of Paraguay in 2004 to that in 2009?
Your answer should be very brief. 1. What is the ratio of the Gross enrolment ratio (%) of Heavily indebted poor countries in 2005 to that in 2006?
Your response must be concise. 0.94. What is the ratio of the Gross enrolment ratio (%) of Marshall Islands in 2005 to that in 2006?
Give a very brief answer. 0.9. What is the ratio of the Gross enrolment ratio (%) of Paraguay in 2005 to that in 2006?
Your answer should be very brief. 1.01. What is the ratio of the Gross enrolment ratio (%) of Central Europe in 2005 to that in 2007?
Make the answer very short. 0.99. What is the ratio of the Gross enrolment ratio (%) of Heavily indebted poor countries in 2005 to that in 2007?
Your answer should be very brief. 0.89. What is the ratio of the Gross enrolment ratio (%) in Marshall Islands in 2005 to that in 2007?
Ensure brevity in your answer.  0.81. What is the ratio of the Gross enrolment ratio (%) of Paraguay in 2005 to that in 2007?
Provide a short and direct response. 1.01. What is the ratio of the Gross enrolment ratio (%) in Central Europe in 2005 to that in 2008?
Provide a short and direct response. 0.98. What is the ratio of the Gross enrolment ratio (%) in Heavily indebted poor countries in 2005 to that in 2008?
Offer a terse response. 0.83. What is the ratio of the Gross enrolment ratio (%) of Marshall Islands in 2005 to that in 2008?
Keep it short and to the point. 0.75. What is the ratio of the Gross enrolment ratio (%) of Central Europe in 2005 to that in 2009?
Your answer should be compact. 0.98. What is the ratio of the Gross enrolment ratio (%) in Heavily indebted poor countries in 2005 to that in 2009?
Your response must be concise. 0.79. What is the ratio of the Gross enrolment ratio (%) of Marshall Islands in 2005 to that in 2009?
Give a very brief answer. 0.74. What is the ratio of the Gross enrolment ratio (%) in Paraguay in 2005 to that in 2009?
Provide a short and direct response. 0.99. What is the ratio of the Gross enrolment ratio (%) in Heavily indebted poor countries in 2006 to that in 2007?
Your answer should be very brief. 0.94. What is the ratio of the Gross enrolment ratio (%) in Marshall Islands in 2006 to that in 2007?
Keep it short and to the point. 0.9. What is the ratio of the Gross enrolment ratio (%) of Central Europe in 2006 to that in 2008?
Provide a short and direct response. 0.98. What is the ratio of the Gross enrolment ratio (%) in Heavily indebted poor countries in 2006 to that in 2008?
Provide a short and direct response. 0.88. What is the ratio of the Gross enrolment ratio (%) of Marshall Islands in 2006 to that in 2008?
Offer a very short reply. 0.83. What is the ratio of the Gross enrolment ratio (%) in Paraguay in 2006 to that in 2008?
Ensure brevity in your answer.  0.99. What is the ratio of the Gross enrolment ratio (%) of Central Europe in 2006 to that in 2009?
Ensure brevity in your answer.  0.98. What is the ratio of the Gross enrolment ratio (%) in Heavily indebted poor countries in 2006 to that in 2009?
Offer a very short reply. 0.84. What is the ratio of the Gross enrolment ratio (%) in Marshall Islands in 2006 to that in 2009?
Offer a very short reply. 0.82. What is the ratio of the Gross enrolment ratio (%) in Paraguay in 2006 to that in 2009?
Give a very brief answer. 0.99. What is the ratio of the Gross enrolment ratio (%) in Central Europe in 2007 to that in 2008?
Provide a short and direct response. 0.99. What is the ratio of the Gross enrolment ratio (%) in Heavily indebted poor countries in 2007 to that in 2008?
Your response must be concise. 0.94. What is the ratio of the Gross enrolment ratio (%) in Marshall Islands in 2007 to that in 2008?
Offer a terse response. 0.92. What is the ratio of the Gross enrolment ratio (%) of Paraguay in 2007 to that in 2008?
Offer a very short reply. 0.99. What is the ratio of the Gross enrolment ratio (%) in Central Europe in 2007 to that in 2009?
Keep it short and to the point. 0.99. What is the ratio of the Gross enrolment ratio (%) in Heavily indebted poor countries in 2007 to that in 2009?
Offer a terse response. 0.89. What is the ratio of the Gross enrolment ratio (%) in Marshall Islands in 2007 to that in 2009?
Make the answer very short. 0.91. What is the ratio of the Gross enrolment ratio (%) in Paraguay in 2007 to that in 2009?
Make the answer very short. 0.98. What is the ratio of the Gross enrolment ratio (%) of Central Europe in 2008 to that in 2009?
Offer a very short reply. 1. What is the ratio of the Gross enrolment ratio (%) in Heavily indebted poor countries in 2008 to that in 2009?
Your answer should be very brief. 0.95. What is the ratio of the Gross enrolment ratio (%) of Marshall Islands in 2008 to that in 2009?
Keep it short and to the point. 0.98. What is the ratio of the Gross enrolment ratio (%) of Paraguay in 2008 to that in 2009?
Make the answer very short. 1. What is the difference between the highest and the second highest Gross enrolment ratio (%) in Central Europe?
Your response must be concise. 0.28. What is the difference between the highest and the second highest Gross enrolment ratio (%) of Heavily indebted poor countries?
Provide a succinct answer. 1.8. What is the difference between the highest and the second highest Gross enrolment ratio (%) in Marshall Islands?
Keep it short and to the point. 2.18. What is the difference between the highest and the second highest Gross enrolment ratio (%) of Paraguay?
Offer a terse response. 0.08. What is the difference between the highest and the lowest Gross enrolment ratio (%) in Central Europe?
Give a very brief answer. 3.42. What is the difference between the highest and the lowest Gross enrolment ratio (%) of Heavily indebted poor countries?
Your answer should be very brief. 10.16. What is the difference between the highest and the lowest Gross enrolment ratio (%) of Marshall Islands?
Ensure brevity in your answer.  31.64. What is the difference between the highest and the lowest Gross enrolment ratio (%) of Paraguay?
Ensure brevity in your answer.  1.28. 